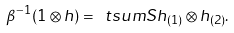Convert formula to latex. <formula><loc_0><loc_0><loc_500><loc_500>\beta ^ { - 1 } ( 1 \otimes { h } ) = \ t s u m S h _ { ( { 1 } ) } \otimes { h _ { ( { 2 } ) } } .</formula> 